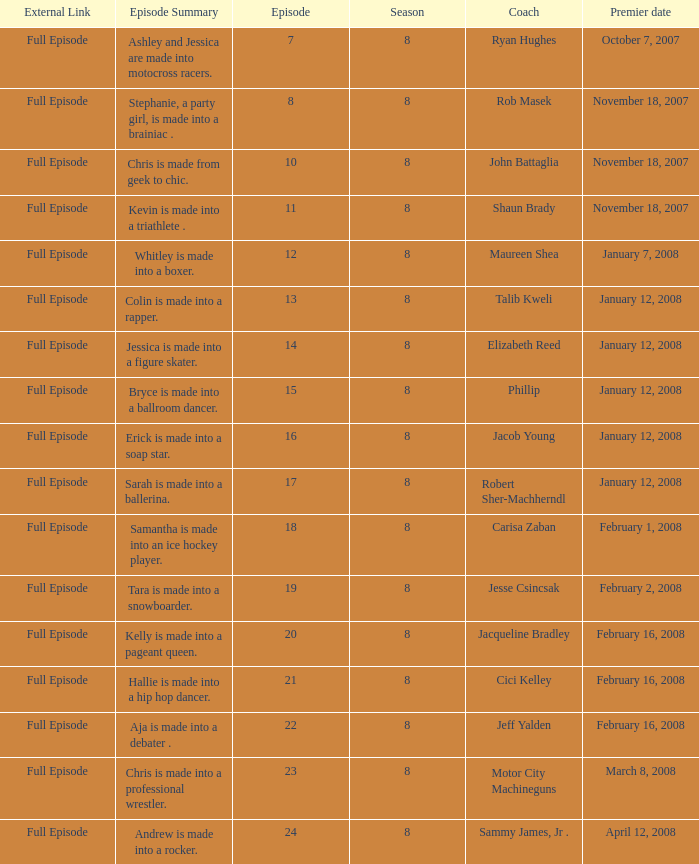How many seasons feature Rob Masek? 1.0. 